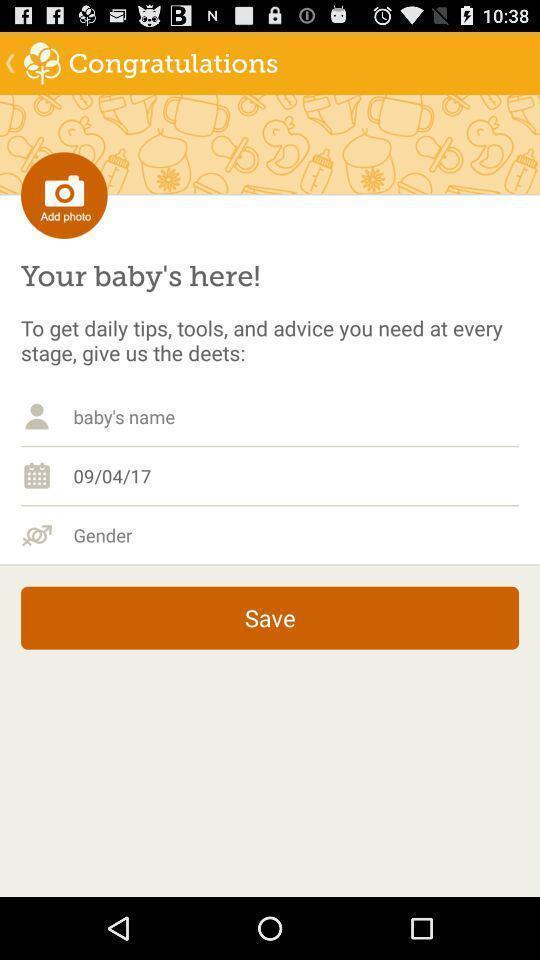Explain the elements present in this screenshot. Screen shows multiple options in a baby health application. 